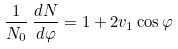Convert formula to latex. <formula><loc_0><loc_0><loc_500><loc_500>\frac { 1 } { N _ { 0 } } \, \frac { d N } { d \varphi } = 1 + 2 v _ { 1 } \cos \varphi</formula> 